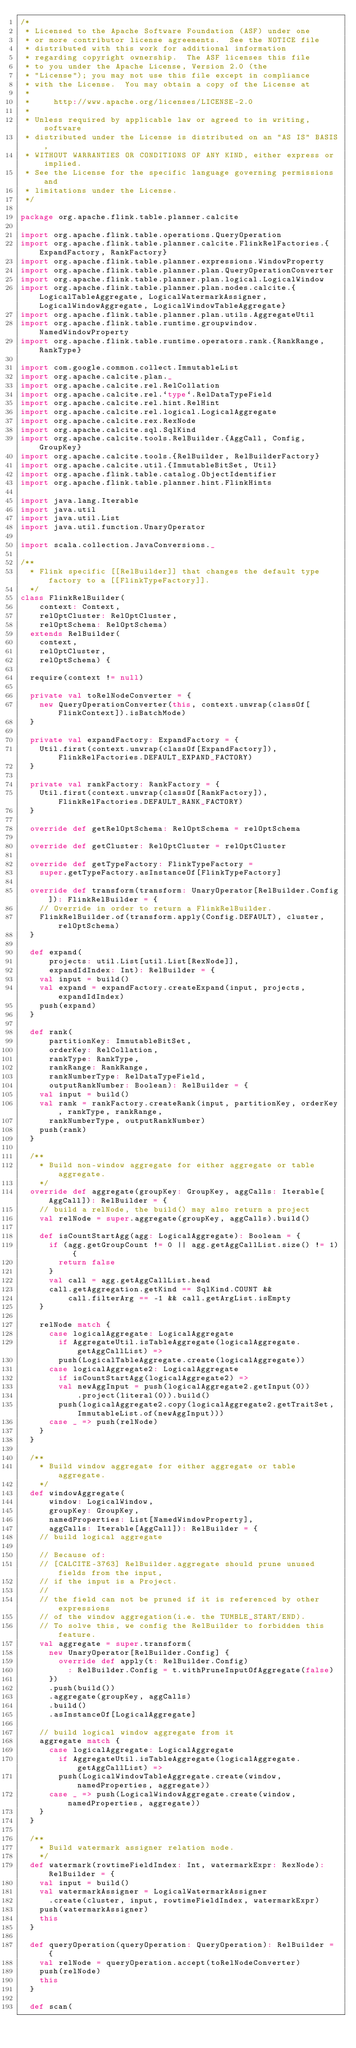Convert code to text. <code><loc_0><loc_0><loc_500><loc_500><_Scala_>/*
 * Licensed to the Apache Software Foundation (ASF) under one
 * or more contributor license agreements.  See the NOTICE file
 * distributed with this work for additional information
 * regarding copyright ownership.  The ASF licenses this file
 * to you under the Apache License, Version 2.0 (the
 * "License"); you may not use this file except in compliance
 * with the License.  You may obtain a copy of the License at
 *
 *     http://www.apache.org/licenses/LICENSE-2.0
 *
 * Unless required by applicable law or agreed to in writing, software
 * distributed under the License is distributed on an "AS IS" BASIS,
 * WITHOUT WARRANTIES OR CONDITIONS OF ANY KIND, either express or implied.
 * See the License for the specific language governing permissions and
 * limitations under the License.
 */

package org.apache.flink.table.planner.calcite

import org.apache.flink.table.operations.QueryOperation
import org.apache.flink.table.planner.calcite.FlinkRelFactories.{ExpandFactory, RankFactory}
import org.apache.flink.table.planner.expressions.WindowProperty
import org.apache.flink.table.planner.plan.QueryOperationConverter
import org.apache.flink.table.planner.plan.logical.LogicalWindow
import org.apache.flink.table.planner.plan.nodes.calcite.{LogicalTableAggregate, LogicalWatermarkAssigner, LogicalWindowAggregate, LogicalWindowTableAggregate}
import org.apache.flink.table.planner.plan.utils.AggregateUtil
import org.apache.flink.table.runtime.groupwindow.NamedWindowProperty
import org.apache.flink.table.runtime.operators.rank.{RankRange, RankType}

import com.google.common.collect.ImmutableList
import org.apache.calcite.plan._
import org.apache.calcite.rel.RelCollation
import org.apache.calcite.rel.`type`.RelDataTypeField
import org.apache.calcite.rel.hint.RelHint
import org.apache.calcite.rel.logical.LogicalAggregate
import org.apache.calcite.rex.RexNode
import org.apache.calcite.sql.SqlKind
import org.apache.calcite.tools.RelBuilder.{AggCall, Config, GroupKey}
import org.apache.calcite.tools.{RelBuilder, RelBuilderFactory}
import org.apache.calcite.util.{ImmutableBitSet, Util}
import org.apache.flink.table.catalog.ObjectIdentifier
import org.apache.flink.table.planner.hint.FlinkHints

import java.lang.Iterable
import java.util
import java.util.List
import java.util.function.UnaryOperator

import scala.collection.JavaConversions._

/**
  * Flink specific [[RelBuilder]] that changes the default type factory to a [[FlinkTypeFactory]].
  */
class FlinkRelBuilder(
    context: Context,
    relOptCluster: RelOptCluster,
    relOptSchema: RelOptSchema)
  extends RelBuilder(
    context,
    relOptCluster,
    relOptSchema) {

  require(context != null)

  private val toRelNodeConverter = {
    new QueryOperationConverter(this, context.unwrap(classOf[FlinkContext]).isBatchMode)
  }

  private val expandFactory: ExpandFactory = {
    Util.first(context.unwrap(classOf[ExpandFactory]), FlinkRelFactories.DEFAULT_EXPAND_FACTORY)
  }

  private val rankFactory: RankFactory = {
    Util.first(context.unwrap(classOf[RankFactory]), FlinkRelFactories.DEFAULT_RANK_FACTORY)
  }

  override def getRelOptSchema: RelOptSchema = relOptSchema

  override def getCluster: RelOptCluster = relOptCluster

  override def getTypeFactory: FlinkTypeFactory =
    super.getTypeFactory.asInstanceOf[FlinkTypeFactory]

  override def transform(transform: UnaryOperator[RelBuilder.Config]): FlinkRelBuilder = {
    // Override in order to return a FlinkRelBuilder.
    FlinkRelBuilder.of(transform.apply(Config.DEFAULT), cluster, relOptSchema)
  }

  def expand(
      projects: util.List[util.List[RexNode]],
      expandIdIndex: Int): RelBuilder = {
    val input = build()
    val expand = expandFactory.createExpand(input, projects, expandIdIndex)
    push(expand)
  }

  def rank(
      partitionKey: ImmutableBitSet,
      orderKey: RelCollation,
      rankType: RankType,
      rankRange: RankRange,
      rankNumberType: RelDataTypeField,
      outputRankNumber: Boolean): RelBuilder = {
    val input = build()
    val rank = rankFactory.createRank(input, partitionKey, orderKey, rankType, rankRange,
      rankNumberType, outputRankNumber)
    push(rank)
  }

  /**
    * Build non-window aggregate for either aggregate or table aggregate.
    */
  override def aggregate(groupKey: GroupKey, aggCalls: Iterable[AggCall]): RelBuilder = {
    // build a relNode, the build() may also return a project
    val relNode = super.aggregate(groupKey, aggCalls).build()

    def isCountStartAgg(agg: LogicalAggregate): Boolean = {
      if (agg.getGroupCount != 0 || agg.getAggCallList.size() != 1) {
        return false
      }
      val call = agg.getAggCallList.head
      call.getAggregation.getKind == SqlKind.COUNT &&
          call.filterArg == -1 && call.getArgList.isEmpty
    }

    relNode match {
      case logicalAggregate: LogicalAggregate
        if AggregateUtil.isTableAggregate(logicalAggregate.getAggCallList) =>
        push(LogicalTableAggregate.create(logicalAggregate))
      case logicalAggregate2: LogicalAggregate
        if isCountStartAgg(logicalAggregate2) =>
        val newAggInput = push(logicalAggregate2.getInput(0))
            .project(literal(0)).build()
        push(logicalAggregate2.copy(logicalAggregate2.getTraitSet, ImmutableList.of(newAggInput)))
      case _ => push(relNode)
    }
  }

  /**
    * Build window aggregate for either aggregate or table aggregate.
    */
  def windowAggregate(
      window: LogicalWindow,
      groupKey: GroupKey,
      namedProperties: List[NamedWindowProperty],
      aggCalls: Iterable[AggCall]): RelBuilder = {
    // build logical aggregate

    // Because of:
    // [CALCITE-3763] RelBuilder.aggregate should prune unused fields from the input,
    // if the input is a Project.
    //
    // the field can not be pruned if it is referenced by other expressions
    // of the window aggregation(i.e. the TUMBLE_START/END).
    // To solve this, we config the RelBuilder to forbidden this feature.
    val aggregate = super.transform(
      new UnaryOperator[RelBuilder.Config] {
        override def apply(t: RelBuilder.Config)
          : RelBuilder.Config = t.withPruneInputOfAggregate(false)
      })
      .push(build())
      .aggregate(groupKey, aggCalls)
      .build()
      .asInstanceOf[LogicalAggregate]

    // build logical window aggregate from it
    aggregate match {
      case logicalAggregate: LogicalAggregate
        if AggregateUtil.isTableAggregate(logicalAggregate.getAggCallList) =>
        push(LogicalWindowTableAggregate.create(window, namedProperties, aggregate))
      case _ => push(LogicalWindowAggregate.create(window, namedProperties, aggregate))
    }
  }

  /**
    * Build watermark assigner relation node.
    */
  def watermark(rowtimeFieldIndex: Int, watermarkExpr: RexNode): RelBuilder = {
    val input = build()
    val watermarkAssigner = LogicalWatermarkAssigner
      .create(cluster, input, rowtimeFieldIndex, watermarkExpr)
    push(watermarkAssigner)
    this
  }

  def queryOperation(queryOperation: QueryOperation): RelBuilder = {
    val relNode = queryOperation.accept(toRelNodeConverter)
    push(relNode)
    this
  }

  def scan(</code> 